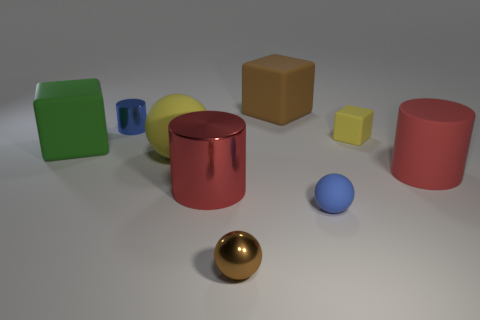There is a blue object that is the same material as the small yellow thing; what size is it?
Offer a very short reply. Small. The blue metal cylinder has what size?
Offer a terse response. Small. Is the color of the big cylinder that is on the left side of the small brown shiny thing the same as the matte cylinder?
Your answer should be very brief. Yes. There is a yellow object that is the same shape as the big brown rubber object; what is its size?
Provide a short and direct response. Small. How many other objects are the same color as the small cylinder?
Keep it short and to the point. 1. Does the big matte cylinder have the same color as the big metal thing?
Keep it short and to the point. Yes. Are there any rubber objects that have the same size as the red metallic cylinder?
Offer a very short reply. Yes. What number of rubber things are both behind the tiny blue sphere and in front of the large brown rubber cube?
Your response must be concise. 4. There is a green rubber block; how many large brown objects are on the right side of it?
Offer a very short reply. 1. Is there another matte object of the same shape as the large brown rubber thing?
Your answer should be very brief. Yes. 